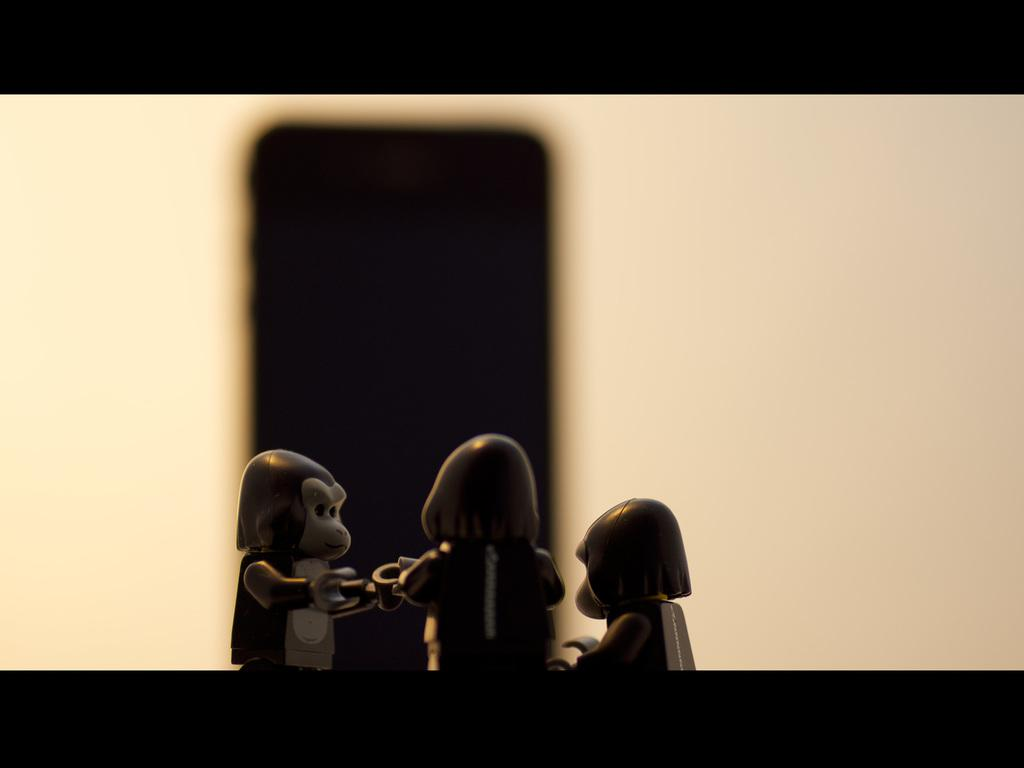What objects are in the foreground of the image? There are three toy monkeys in the foreground of the image. What can be seen on the wall in the image? There is a shadow of a mobile on a wall in the image. What design element is present at the top and bottom of the image? There is a black border at the top and bottom of the image. What type of star can be seen in the image? There is no star present in the image. Can you tell me the color of the vase in the image? There is no vase present in the image. 